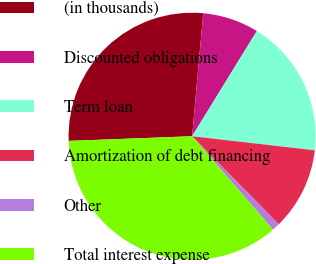<chart> <loc_0><loc_0><loc_500><loc_500><pie_chart><fcel>(in thousands)<fcel>Discounted obligations<fcel>Term loan<fcel>Amortization of debt financing<fcel>Other<fcel>Total interest expense<nl><fcel>27.04%<fcel>7.34%<fcel>18.04%<fcel>10.81%<fcel>1.01%<fcel>35.76%<nl></chart> 